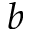Convert formula to latex. <formula><loc_0><loc_0><loc_500><loc_500>b</formula> 